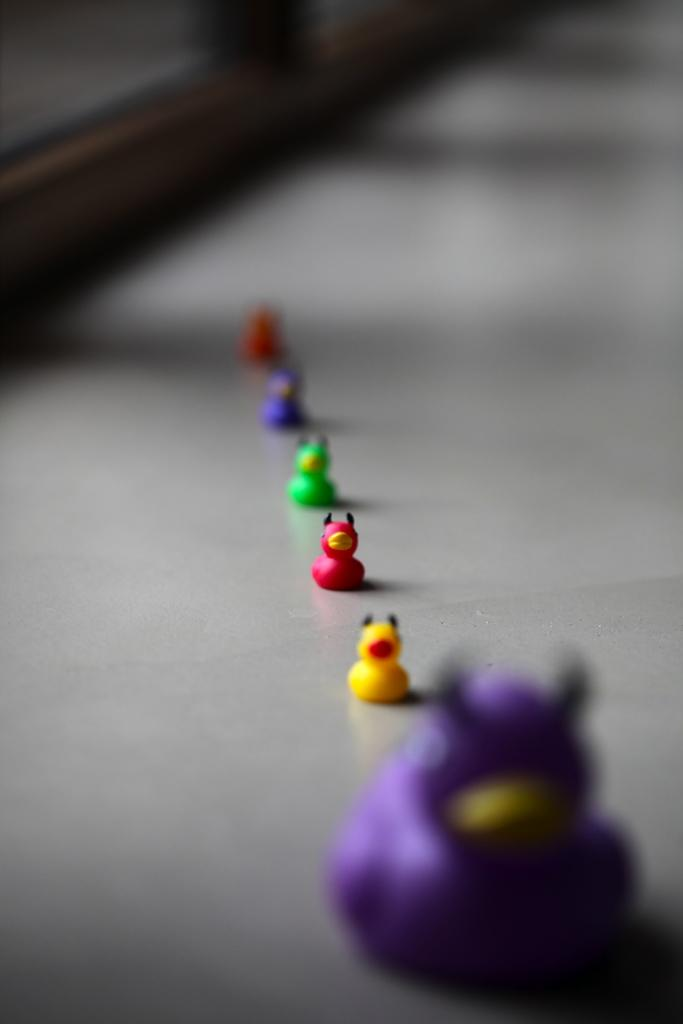What is on the floor in the image? There are toys on the floor. Can you describe the object at the top of the image? Unfortunately, the provided facts do not give any information about the object at the top of the image. How does the van start in the image? There is no van present in the image, so it is not possible to answer that question. 